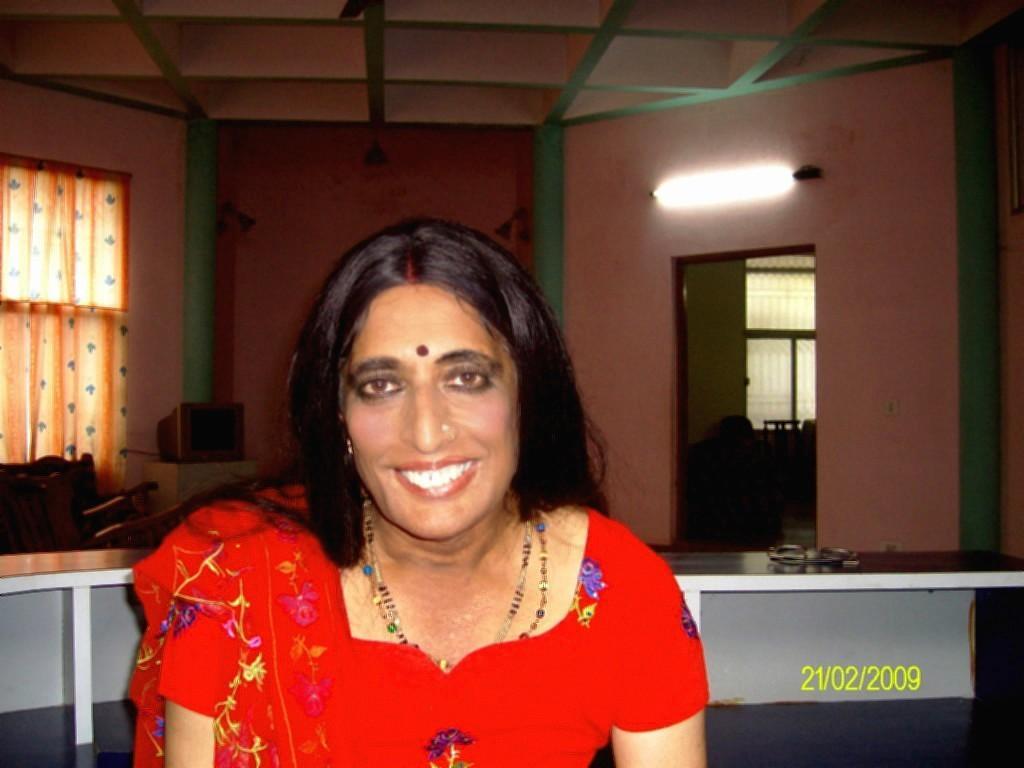Can you describe this image briefly? In the image we can see a woman wearing clothes, neck chain, nose stud and she is smiling. Behind here we can see the window, curtains and the television. Here we can see the wall, light and on the bottom right we can see the watermark. 